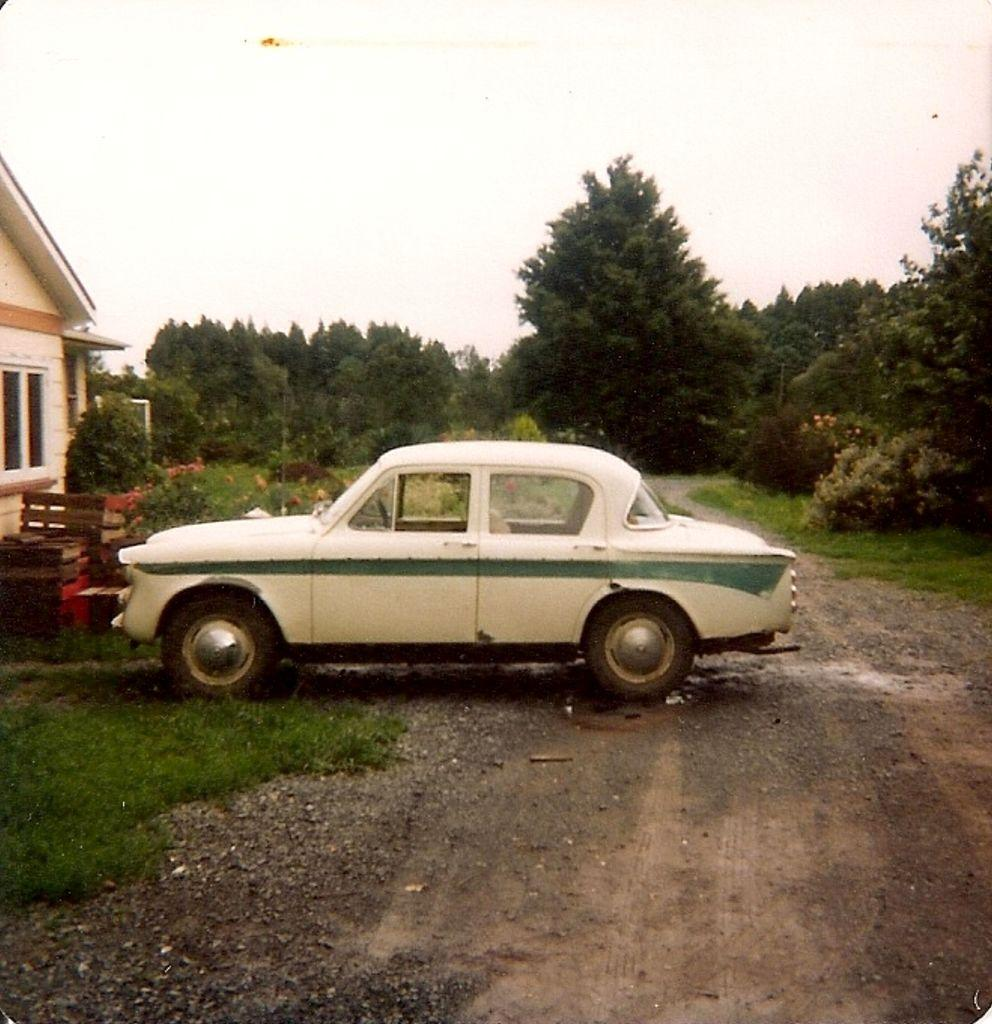What is the main subject in the center of the image? There is a car in the center of the image. Where is the car located? The car is on the road. What type of vegetation can be seen in the image? There is grass visible in the image. What is visible in the background of the image? There are trees in the background of the image. What structure is located to the left side of the image? There is a house to the left side of the image. What is visible at the top of the image? The sky is visible in the image. How many legs can be seen on the kitten in the image? There is no kitten present in the image, so it is not possible to determine the number of legs. 